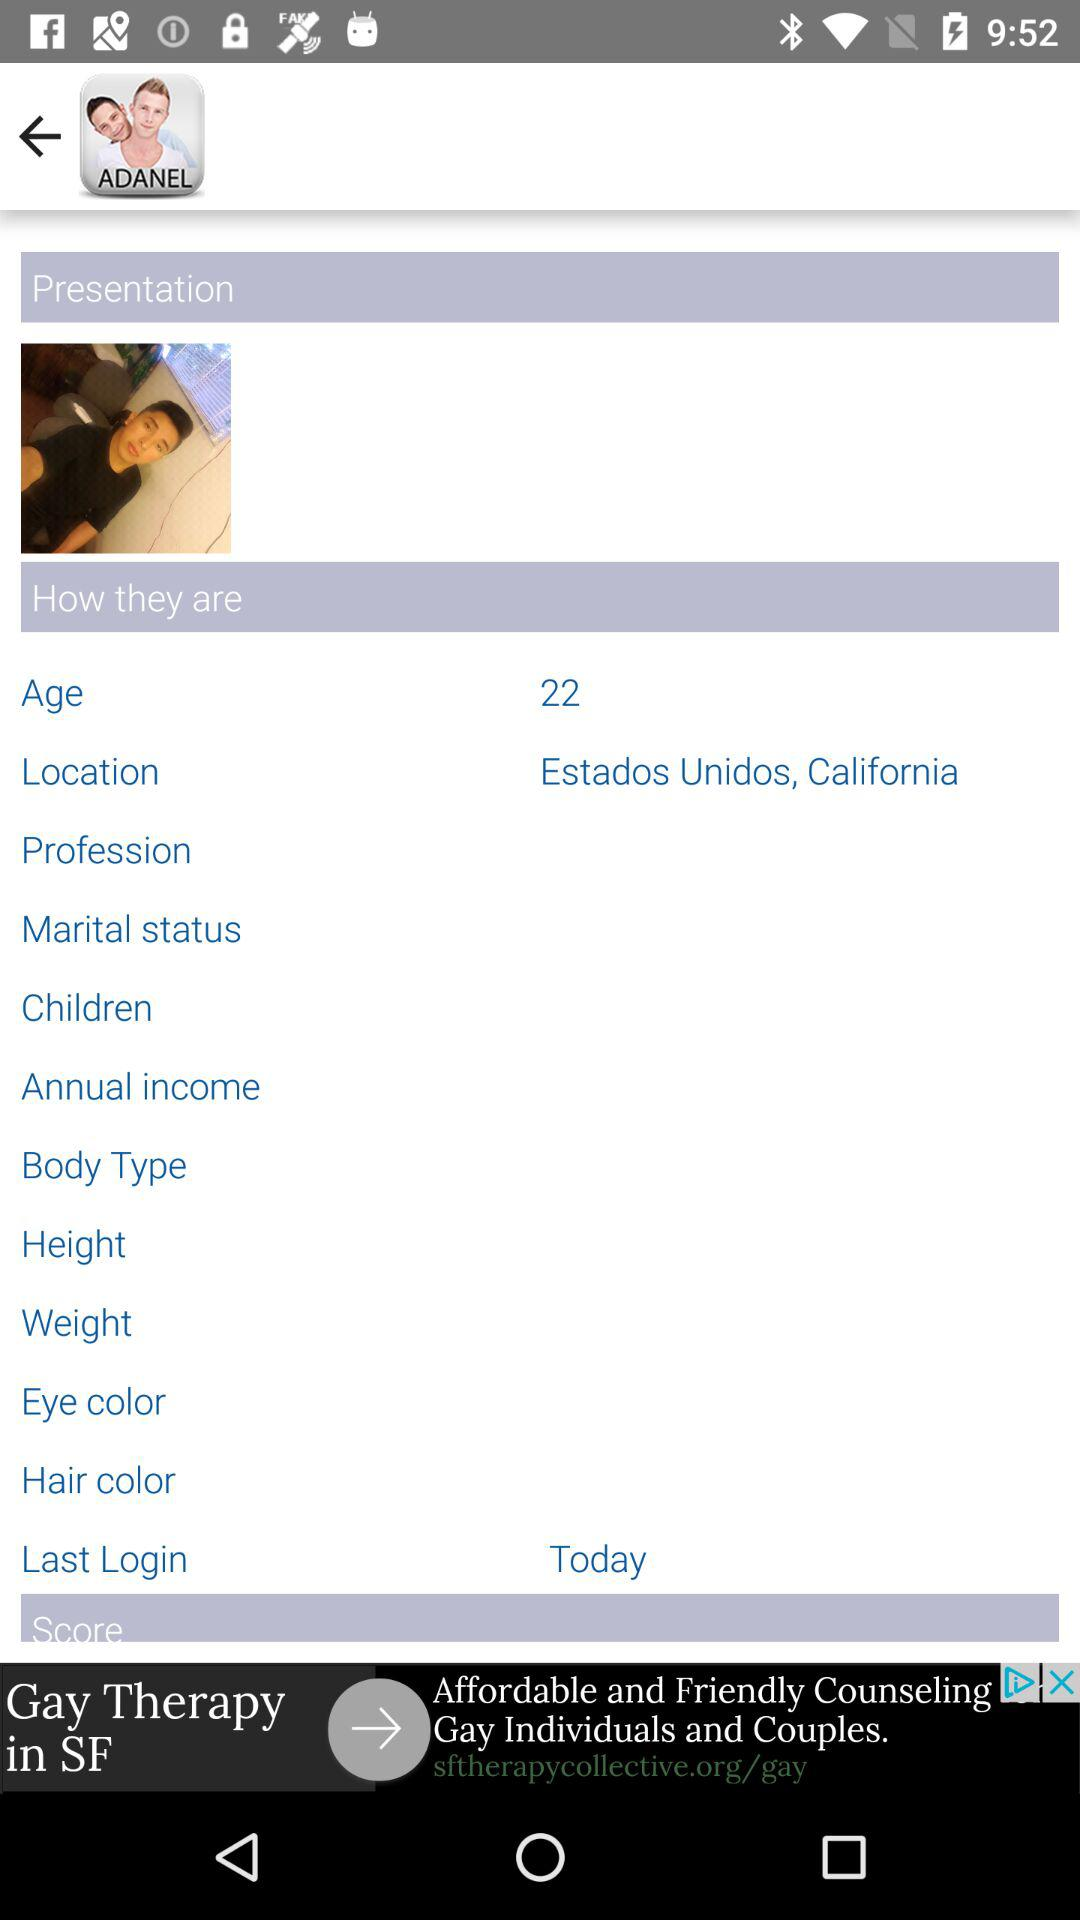What is the age? The age is 22. 